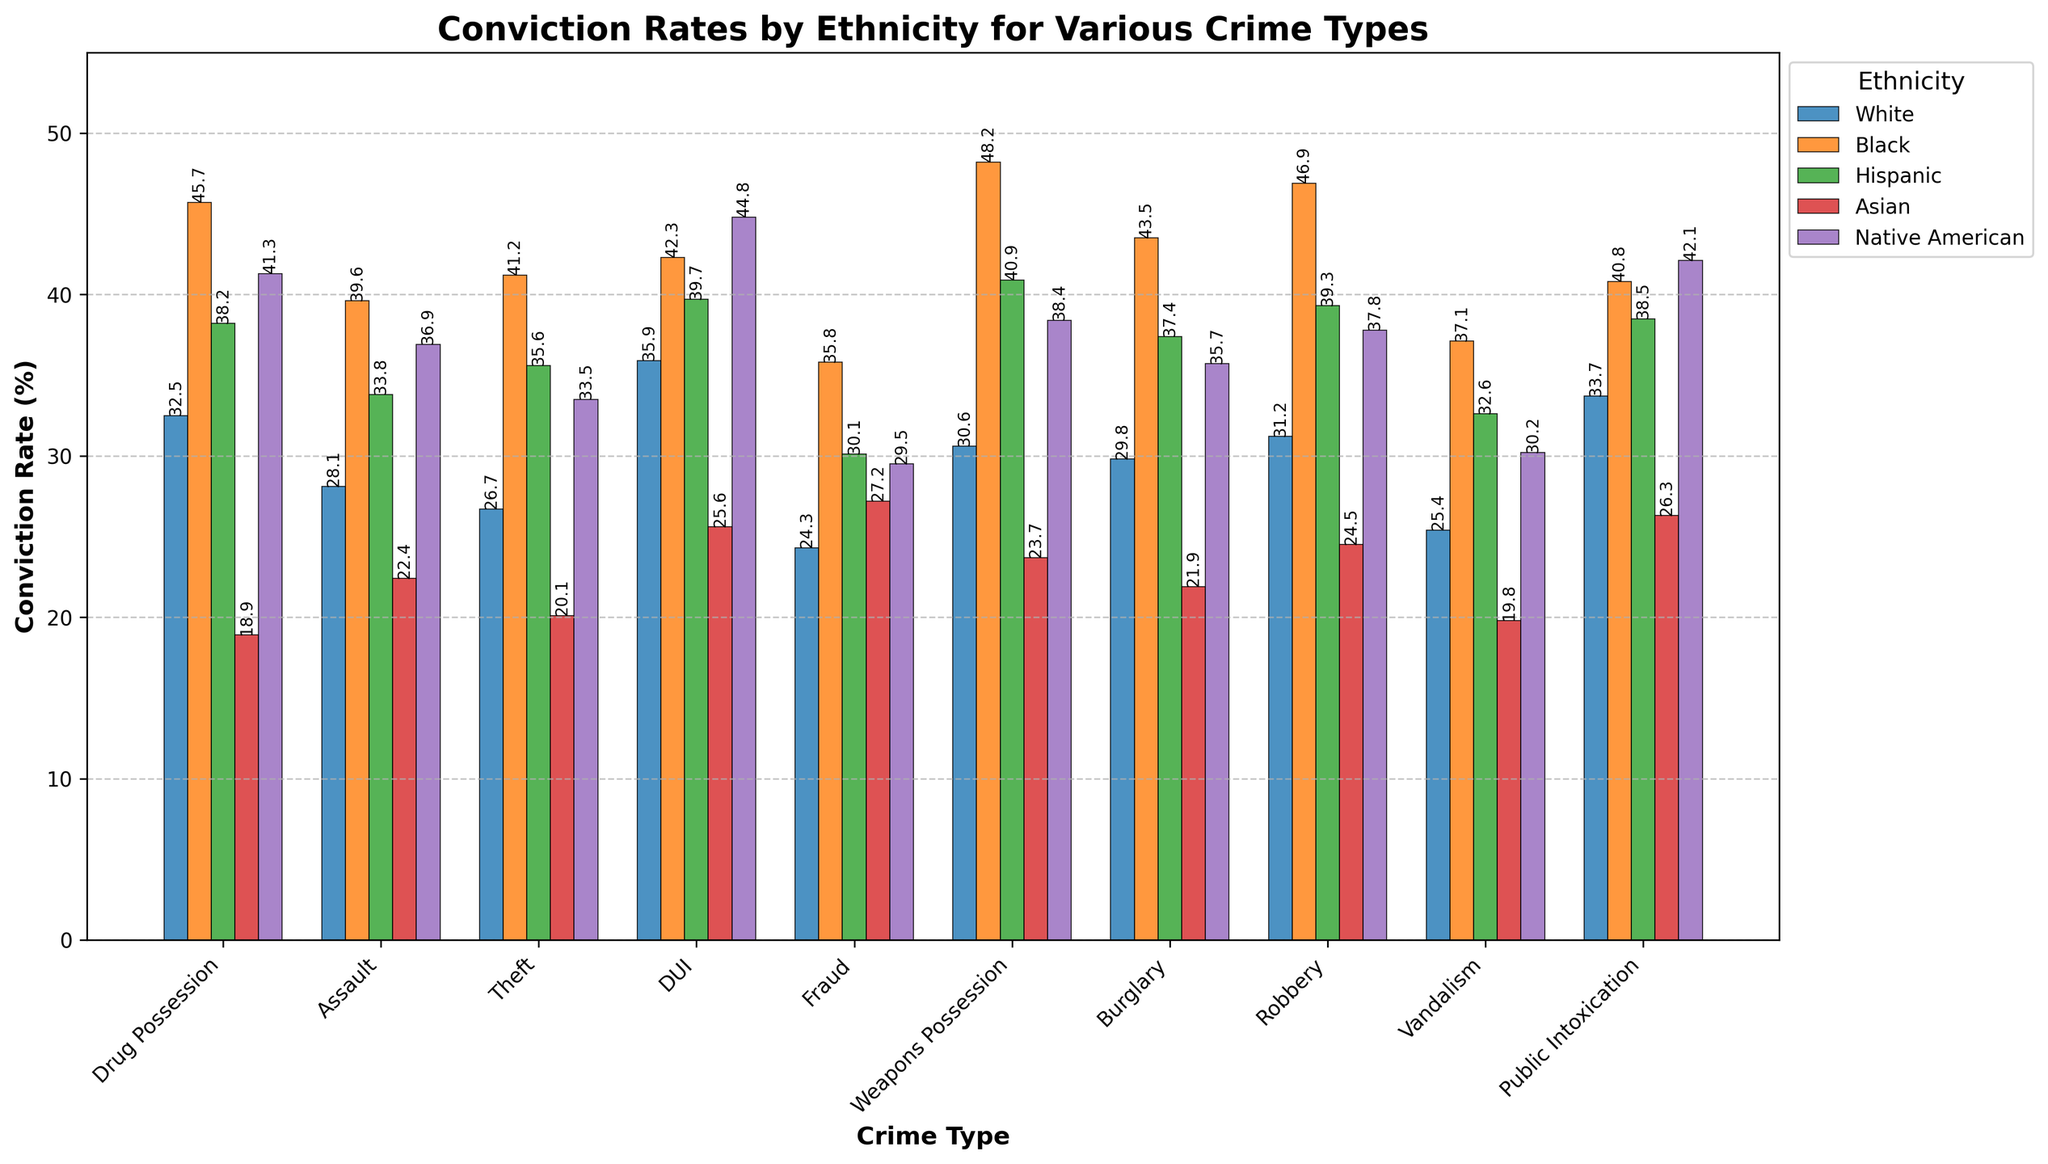Which crime has the highest conviction rate for Black ethnicity? Look at the highest bar for Black ethnicity in the chart. The bar for "Weapons Possession" is the tallest among Black ethnicities with a value of 48.2%
Answer: Weapons Possession Which ethnicity has the highest average conviction rate across all crime types? Calculate the average conviction rate for each ethnicity by summing the values and then dividing by the number of crime types. The sum totals are: White (298.2), Black (421.1), Hispanic (366.1), Asian (230.4), Native American (369.2). Dividing by 10 gives averages of White (29.82), Black (42.11), Hispanic (36.61), Asian (23.04), Native American (36.92). Black ethnicity has the highest average.
Answer: Black Which crime has the lowest conviction rate for Asian ethnicity? Look at the lowest bar for Asian ethnicity in the chart. "Drug Possession" has the lowest conviction rate with 18.9%
Answer: Drug Possession Compare the conviction rates for Public Intoxication between Hispanic and Native American ethnicities. Which is higher and by how much? Check the bars for Public Intoxication for Hispanic (38.5) and Native American (42.1). Subtract the Hispanic rate from the Native American rate (42.1 - 38.5)
Answer: Native American by 3.6% What is the total combined conviction rate for Black ethnicity in Assault and Robbery? Find and add the values for Black ethnicity in Assault (39.6) and Robbery (46.9). The total is 39.6 + 46.9 = 86.5
Answer: 86.5 Which crime type has the most variation in conviction rates across all ethnicities? Look at the range of conviction rates by calculating the difference between the highest and lowest values for each crime type. "Drug Possession" has the most variation (45.7 - 18.9 = 26.8)
Answer: Drug Possession What is the difference in conviction rates between White and Hispanic ethnicities for Vandalism? Find Vandalism conviction rates for White (25.4) and Hispanic (32.6). Subtract the White rate from the Hispanic rate (32.6 - 25.4)
Answer: 7.2 For which crime type do White and Native American ethnicities have the closest conviction rates? Calculate the absolute differences for each crime type. "Robbery" has the smallest difference (37.8 - 31.2 = 6.6)
Answer: Robbery What is the median conviction rate for Hispanic ethnicity across all crime types? List all Hispanic values: {38.2, 33.8, 35.6, 39.7, 30.1, 40.9, 37.4, 39.3, 32.6, 38.5} and find the median (middle value of sorted list: {30.1, 32.6, 33.8, 35.6, 37.4, 38.2, 38.5, 39.3, 39.7, 40.9}) which is average of 37.4 and 38.2. (37.4 + 38.2) / 2 = 37.8
Answer: 37.8 